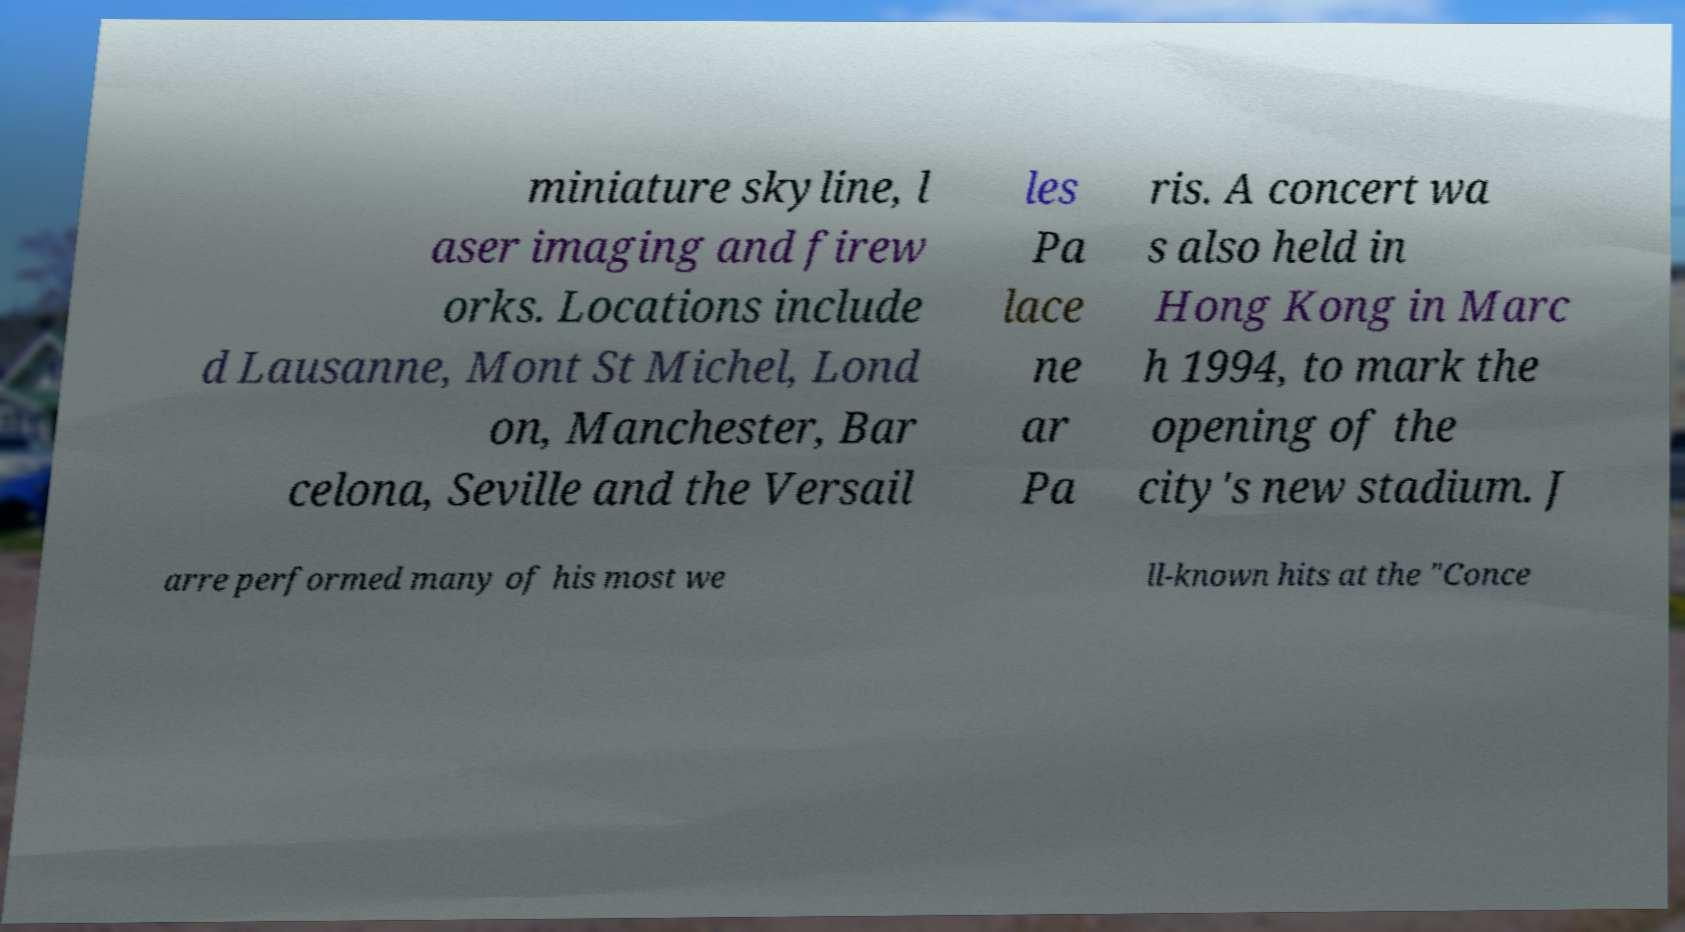There's text embedded in this image that I need extracted. Can you transcribe it verbatim? miniature skyline, l aser imaging and firew orks. Locations include d Lausanne, Mont St Michel, Lond on, Manchester, Bar celona, Seville and the Versail les Pa lace ne ar Pa ris. A concert wa s also held in Hong Kong in Marc h 1994, to mark the opening of the city's new stadium. J arre performed many of his most we ll-known hits at the "Conce 